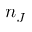<formula> <loc_0><loc_0><loc_500><loc_500>n _ { J }</formula> 